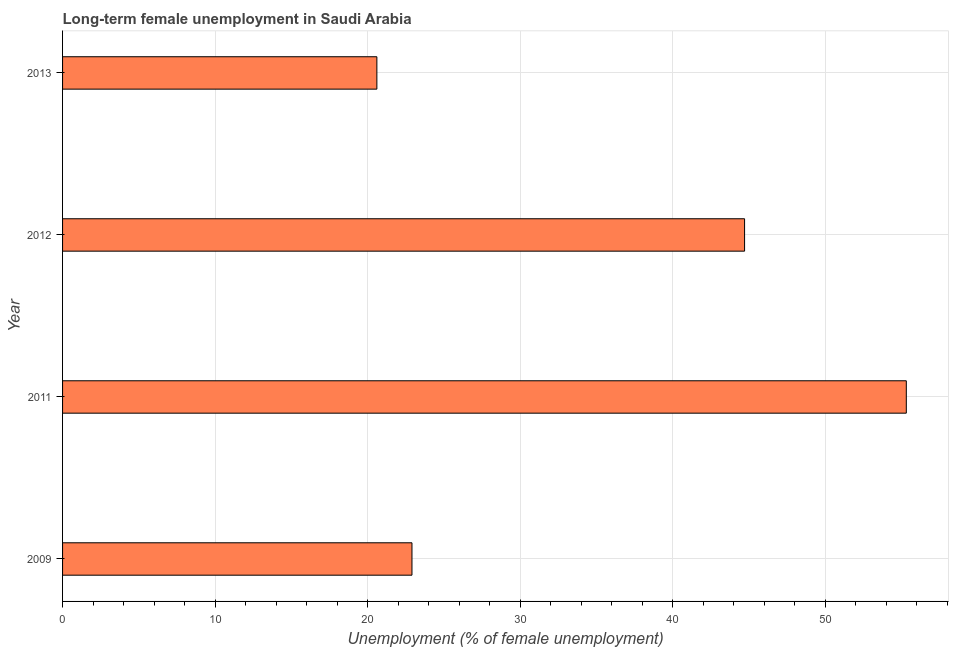Does the graph contain grids?
Provide a succinct answer. Yes. What is the title of the graph?
Your answer should be very brief. Long-term female unemployment in Saudi Arabia. What is the label or title of the X-axis?
Make the answer very short. Unemployment (% of female unemployment). What is the long-term female unemployment in 2013?
Give a very brief answer. 20.6. Across all years, what is the maximum long-term female unemployment?
Your answer should be very brief. 55.3. Across all years, what is the minimum long-term female unemployment?
Provide a succinct answer. 20.6. In which year was the long-term female unemployment maximum?
Your answer should be compact. 2011. In which year was the long-term female unemployment minimum?
Make the answer very short. 2013. What is the sum of the long-term female unemployment?
Offer a very short reply. 143.5. What is the difference between the long-term female unemployment in 2009 and 2013?
Your response must be concise. 2.3. What is the average long-term female unemployment per year?
Offer a very short reply. 35.88. What is the median long-term female unemployment?
Your answer should be very brief. 33.8. What is the ratio of the long-term female unemployment in 2009 to that in 2011?
Offer a very short reply. 0.41. What is the difference between the highest and the second highest long-term female unemployment?
Keep it short and to the point. 10.6. What is the difference between the highest and the lowest long-term female unemployment?
Keep it short and to the point. 34.7. What is the Unemployment (% of female unemployment) of 2009?
Offer a very short reply. 22.9. What is the Unemployment (% of female unemployment) of 2011?
Ensure brevity in your answer.  55.3. What is the Unemployment (% of female unemployment) of 2012?
Offer a terse response. 44.7. What is the Unemployment (% of female unemployment) in 2013?
Offer a terse response. 20.6. What is the difference between the Unemployment (% of female unemployment) in 2009 and 2011?
Keep it short and to the point. -32.4. What is the difference between the Unemployment (% of female unemployment) in 2009 and 2012?
Your answer should be compact. -21.8. What is the difference between the Unemployment (% of female unemployment) in 2011 and 2013?
Ensure brevity in your answer.  34.7. What is the difference between the Unemployment (% of female unemployment) in 2012 and 2013?
Your answer should be compact. 24.1. What is the ratio of the Unemployment (% of female unemployment) in 2009 to that in 2011?
Your answer should be very brief. 0.41. What is the ratio of the Unemployment (% of female unemployment) in 2009 to that in 2012?
Your answer should be very brief. 0.51. What is the ratio of the Unemployment (% of female unemployment) in 2009 to that in 2013?
Ensure brevity in your answer.  1.11. What is the ratio of the Unemployment (% of female unemployment) in 2011 to that in 2012?
Your answer should be very brief. 1.24. What is the ratio of the Unemployment (% of female unemployment) in 2011 to that in 2013?
Offer a terse response. 2.68. What is the ratio of the Unemployment (% of female unemployment) in 2012 to that in 2013?
Your answer should be very brief. 2.17. 